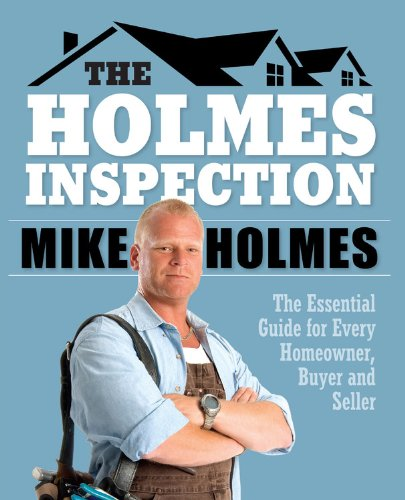Who wrote this book? The book is authored by Mike Holmes, a well-known figure in the home inspection and improvement industry. 